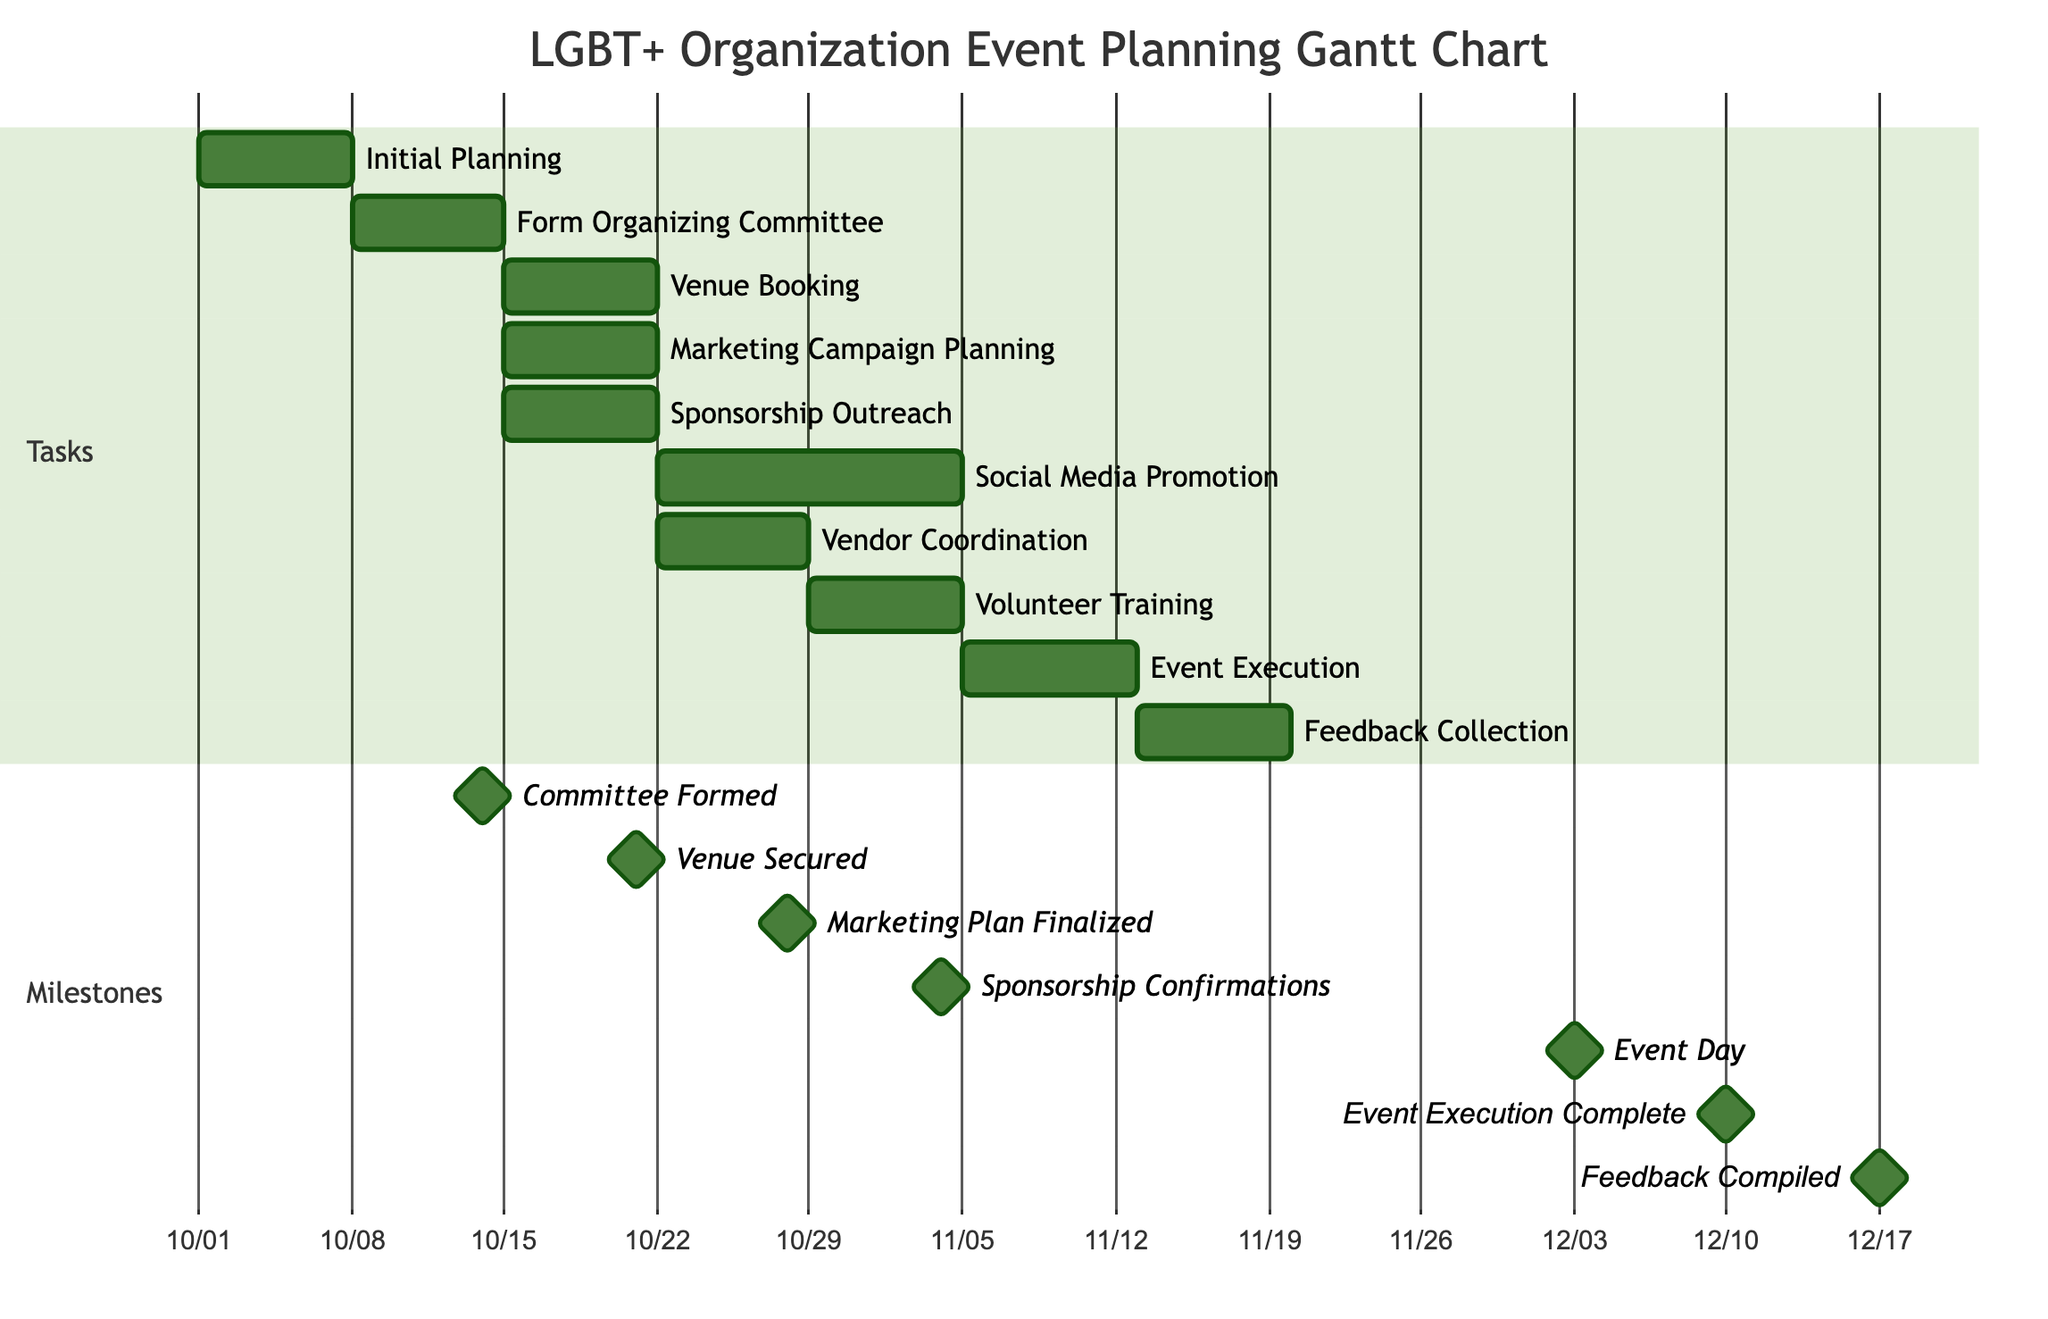What is the first task in the event planning process? The diagram starts with the "Initial Planning" task, which is listed as the first task.
Answer: Initial Planning How many days does the "Social Media Promotion" task take? The task "Social Media Promotion" is indicated to take 14 days in the timeline.
Answer: 14 days What are the dependencies for "Event Execution"? "Event Execution" depends on three tasks: "Sponsorship Outreach," "Social Media Promotion," and "Volunteer Training."
Answer: Sponsorship Outreach, Social Media Promotion, Volunteer Training On what date is the "Committee Formed" milestone achieved? The diagram shows that the "Committee Formed" milestone is set for October 14, 2023.
Answer: 2023-10-14 Which task follows after the "Venue Booking"? The task that follows "Venue Booking" is "Vendor Coordination," which is scheduled immediately after it in the timeline.
Answer: Vendor Coordination How many milestones are present in the diagram? The diagram displays a total of 7 milestones that mark significant points in the planning process.
Answer: 7 What is the milestone date for "Event Day"? The "Event Day" milestone is marked for December 3, 2023, as shown in the diagram.
Answer: 2023-12-03 What task must be completed before "Volunteer Training"? "Vendor Coordination" must be completed before proceeding with "Volunteer Training." This is indicated by the dependency relationship in the diagram.
Answer: Vendor Coordination What task has the longest duration in the tasks section? The task with the longest duration in the tasks section is "Social Media Promotion," taking a total of 14 days.
Answer: Social Media Promotion 